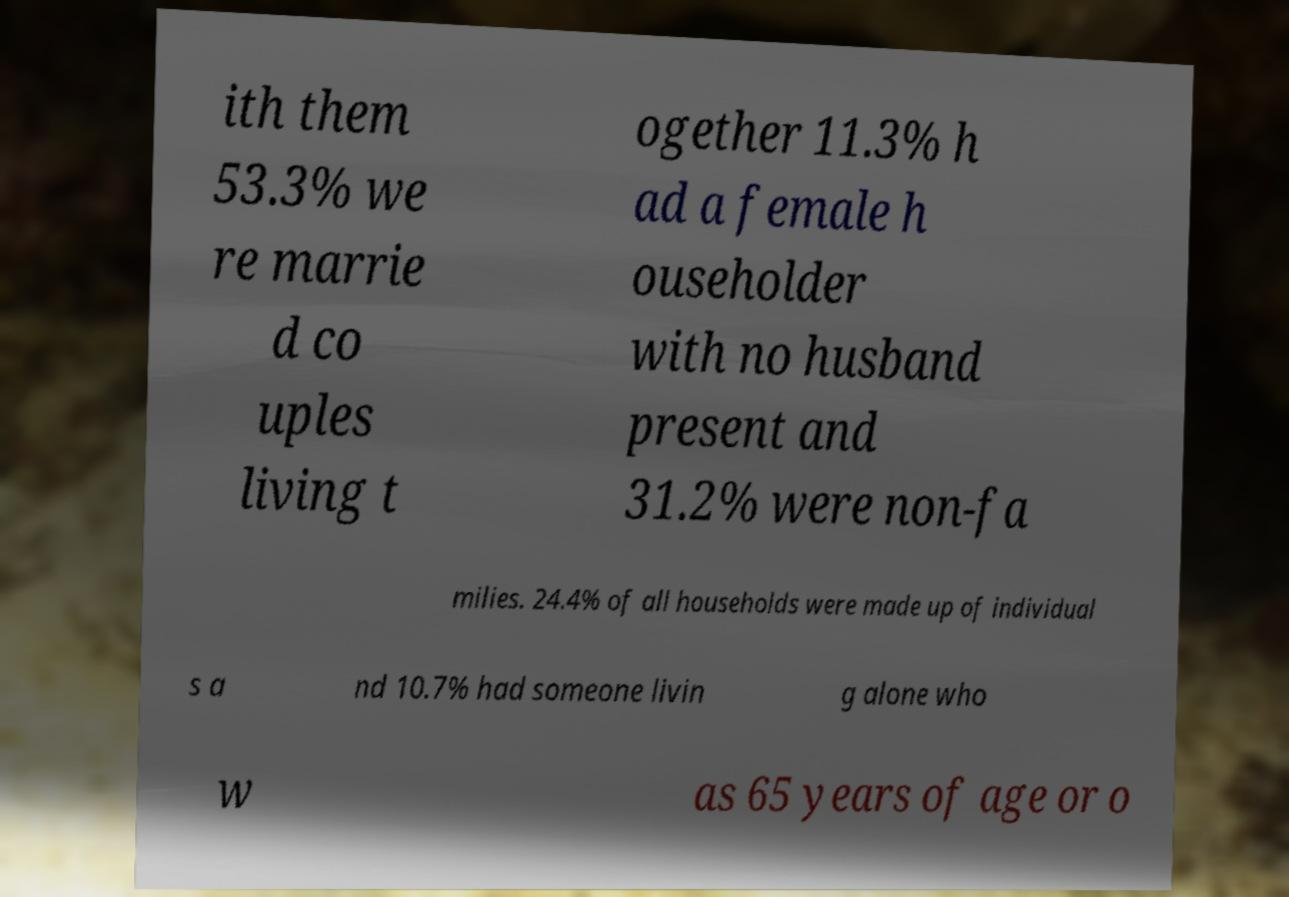What messages or text are displayed in this image? I need them in a readable, typed format. ith them 53.3% we re marrie d co uples living t ogether 11.3% h ad a female h ouseholder with no husband present and 31.2% were non-fa milies. 24.4% of all households were made up of individual s a nd 10.7% had someone livin g alone who w as 65 years of age or o 